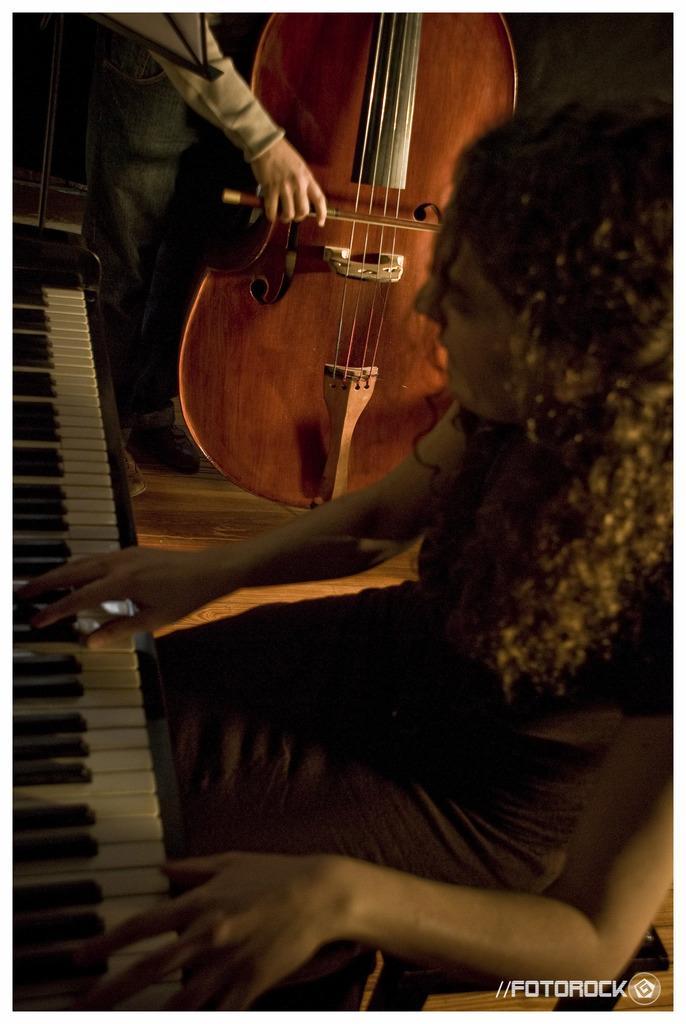Please provide a concise description of this image. In a picture one woman is sitting and playing the keyboards and beside her there is one person is standing and playing violin. 